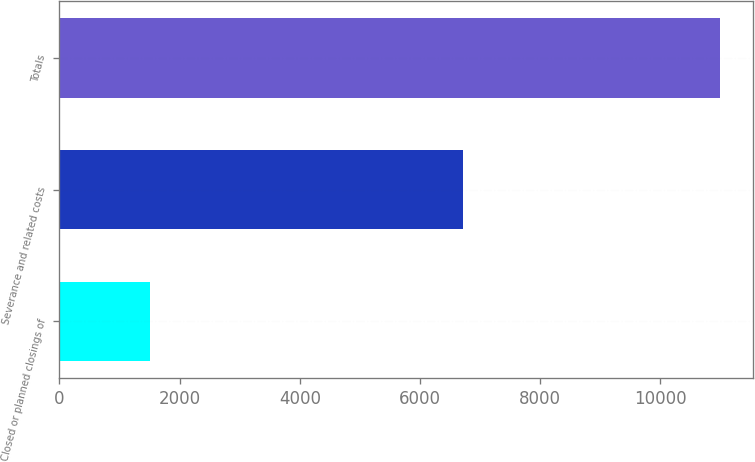Convert chart. <chart><loc_0><loc_0><loc_500><loc_500><bar_chart><fcel>Closed or planned closings of<fcel>Severance and related costs<fcel>Totals<nl><fcel>1512<fcel>6715<fcel>10993<nl></chart> 